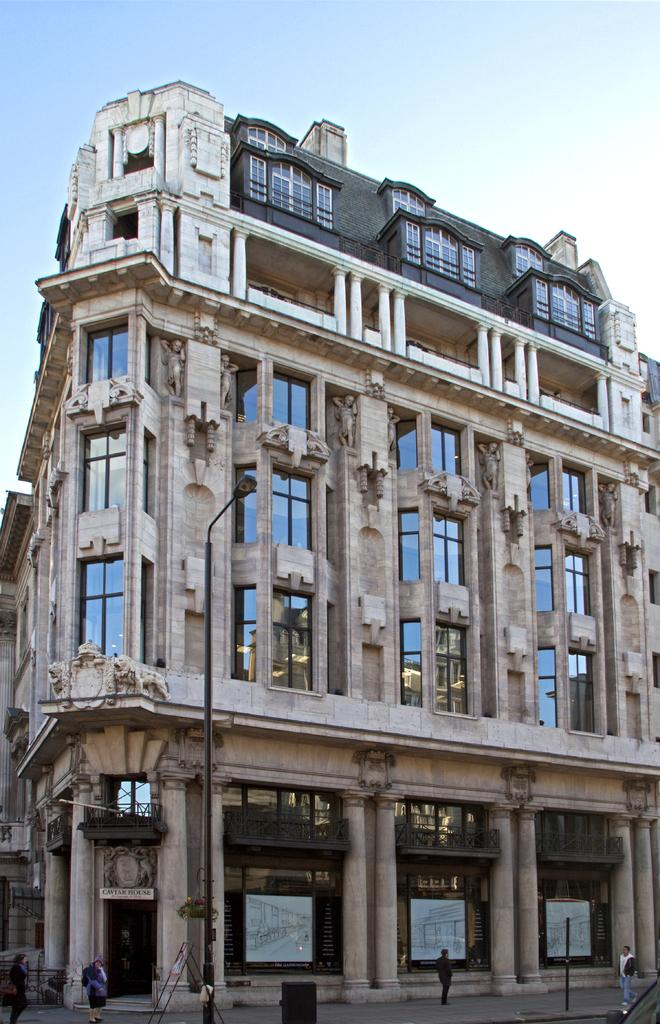What are the people in the image doing? There are persons walking in the image. What objects can be seen in the image besides the people? There are poles in the image. What can be seen in the background of the image? There is a building in the background of the image. What is the condition of the sky in the image? The sky is cloudy in the image. What type of reward is being given to the government in the image? There is no mention of a reward or the government in the image; it features people walking and poles. What kind of bottle can be seen in the hands of the persons walking in the image? There is no bottle visible in the hands of the persons walking in the image. 